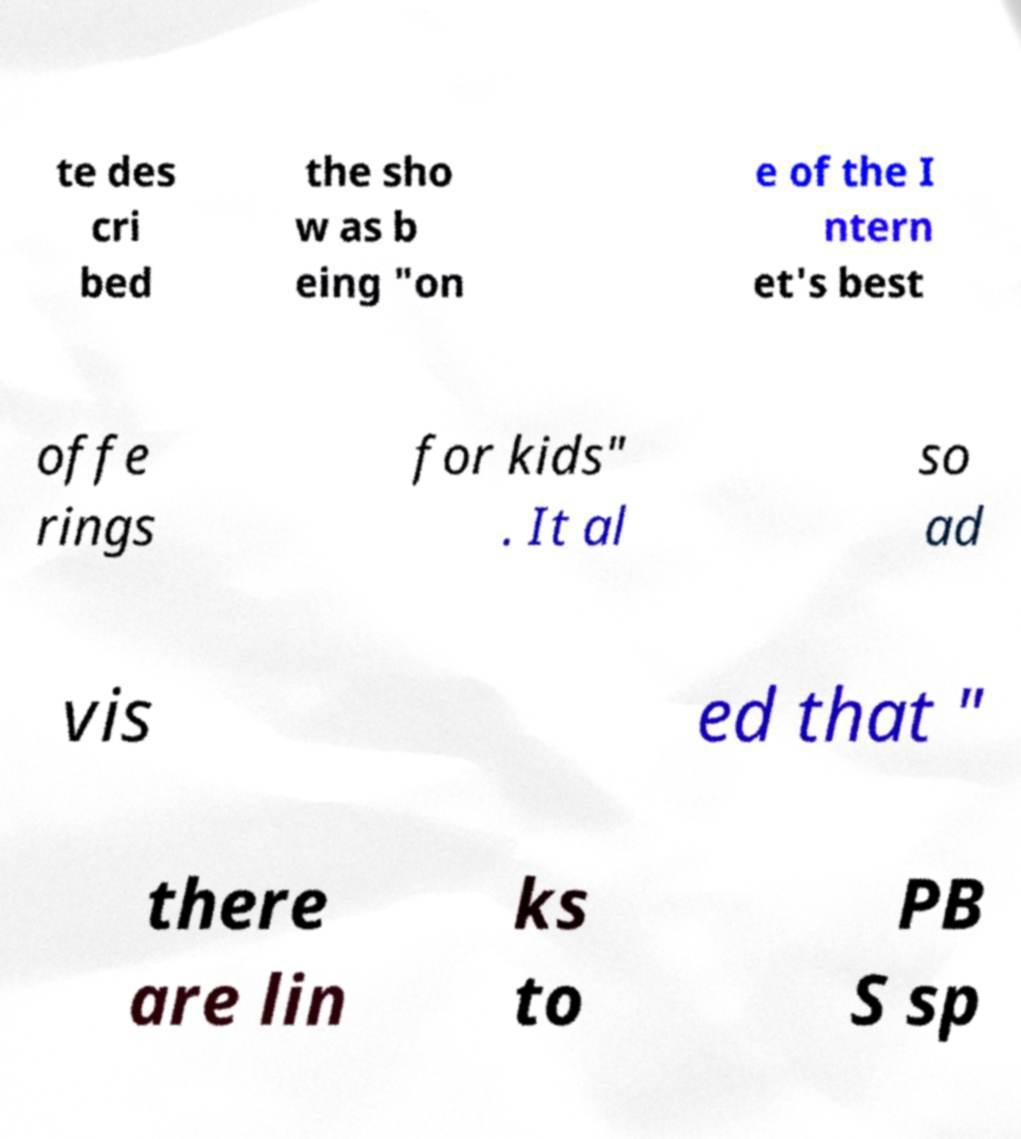Could you assist in decoding the text presented in this image and type it out clearly? te des cri bed the sho w as b eing "on e of the I ntern et's best offe rings for kids" . It al so ad vis ed that " there are lin ks to PB S sp 